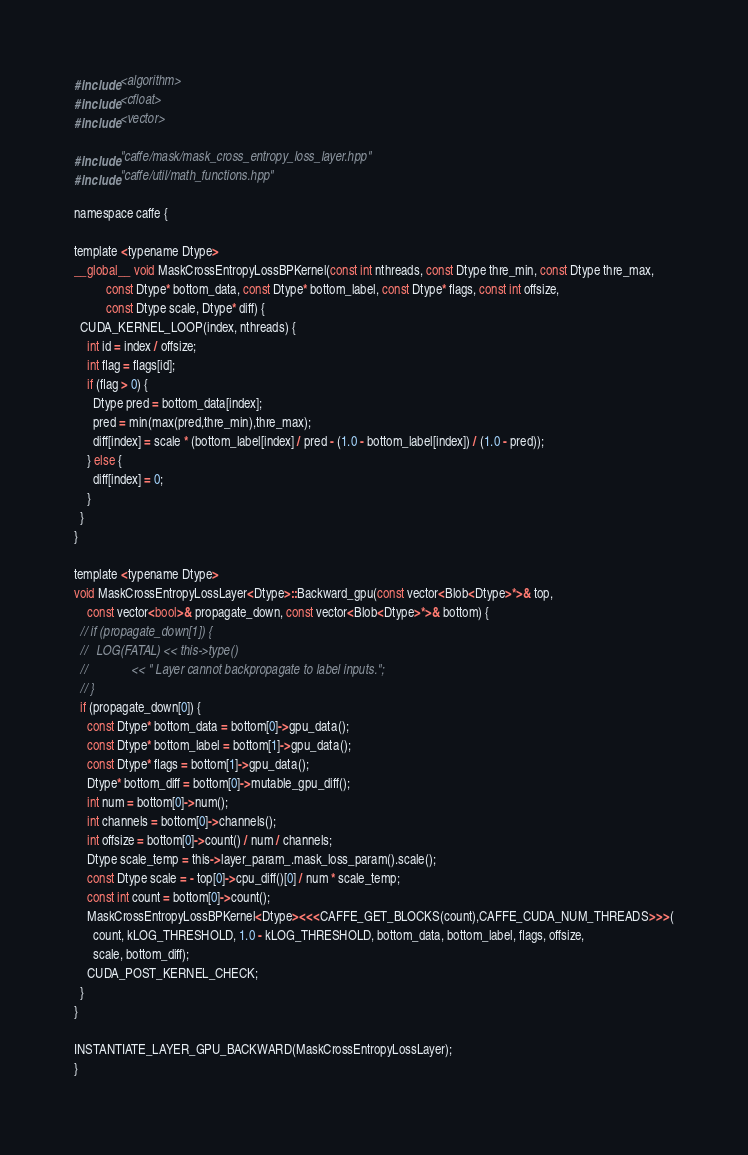<code> <loc_0><loc_0><loc_500><loc_500><_Cuda_>#include <algorithm>
#include <cfloat>
#include <vector>

#include "caffe/mask/mask_cross_entropy_loss_layer.hpp"
#include "caffe/util/math_functions.hpp"

namespace caffe {

template <typename Dtype>
__global__ void MaskCrossEntropyLossBPKernel(const int nthreads, const Dtype thre_min, const Dtype thre_max,
          const Dtype* bottom_data, const Dtype* bottom_label, const Dtype* flags, const int offsize,
          const Dtype scale, Dtype* diff) {
  CUDA_KERNEL_LOOP(index, nthreads) {
    int id = index / offsize;
    int flag = flags[id];
    if (flag > 0) {
      Dtype pred = bottom_data[index];
      pred = min(max(pred,thre_min),thre_max);
      diff[index] = scale * (bottom_label[index] / pred - (1.0 - bottom_label[index]) / (1.0 - pred));
    } else {
      diff[index] = 0;
    }
  }
}

template <typename Dtype>
void MaskCrossEntropyLossLayer<Dtype>::Backward_gpu(const vector<Blob<Dtype>*>& top,
    const vector<bool>& propagate_down, const vector<Blob<Dtype>*>& bottom) {
  // if (propagate_down[1]) {
  //   LOG(FATAL) << this->type()
  //              << " Layer cannot backpropagate to label inputs.";
  // }
  if (propagate_down[0]) {
    const Dtype* bottom_data = bottom[0]->gpu_data();
    const Dtype* bottom_label = bottom[1]->gpu_data();
    const Dtype* flags = bottom[1]->gpu_data();
    Dtype* bottom_diff = bottom[0]->mutable_gpu_diff();
    int num = bottom[0]->num();
    int channels = bottom[0]->channels();
    int offsize = bottom[0]->count() / num / channels;
    Dtype scale_temp = this->layer_param_.mask_loss_param().scale();
    const Dtype scale = - top[0]->cpu_diff()[0] / num * scale_temp;
    const int count = bottom[0]->count();
    MaskCrossEntropyLossBPKernel<Dtype><<<CAFFE_GET_BLOCKS(count),CAFFE_CUDA_NUM_THREADS>>>(
      count, kLOG_THRESHOLD, 1.0 - kLOG_THRESHOLD, bottom_data, bottom_label, flags, offsize,
      scale, bottom_diff);
    CUDA_POST_KERNEL_CHECK;
  }
}

INSTANTIATE_LAYER_GPU_BACKWARD(MaskCrossEntropyLossLayer);
}
</code> 